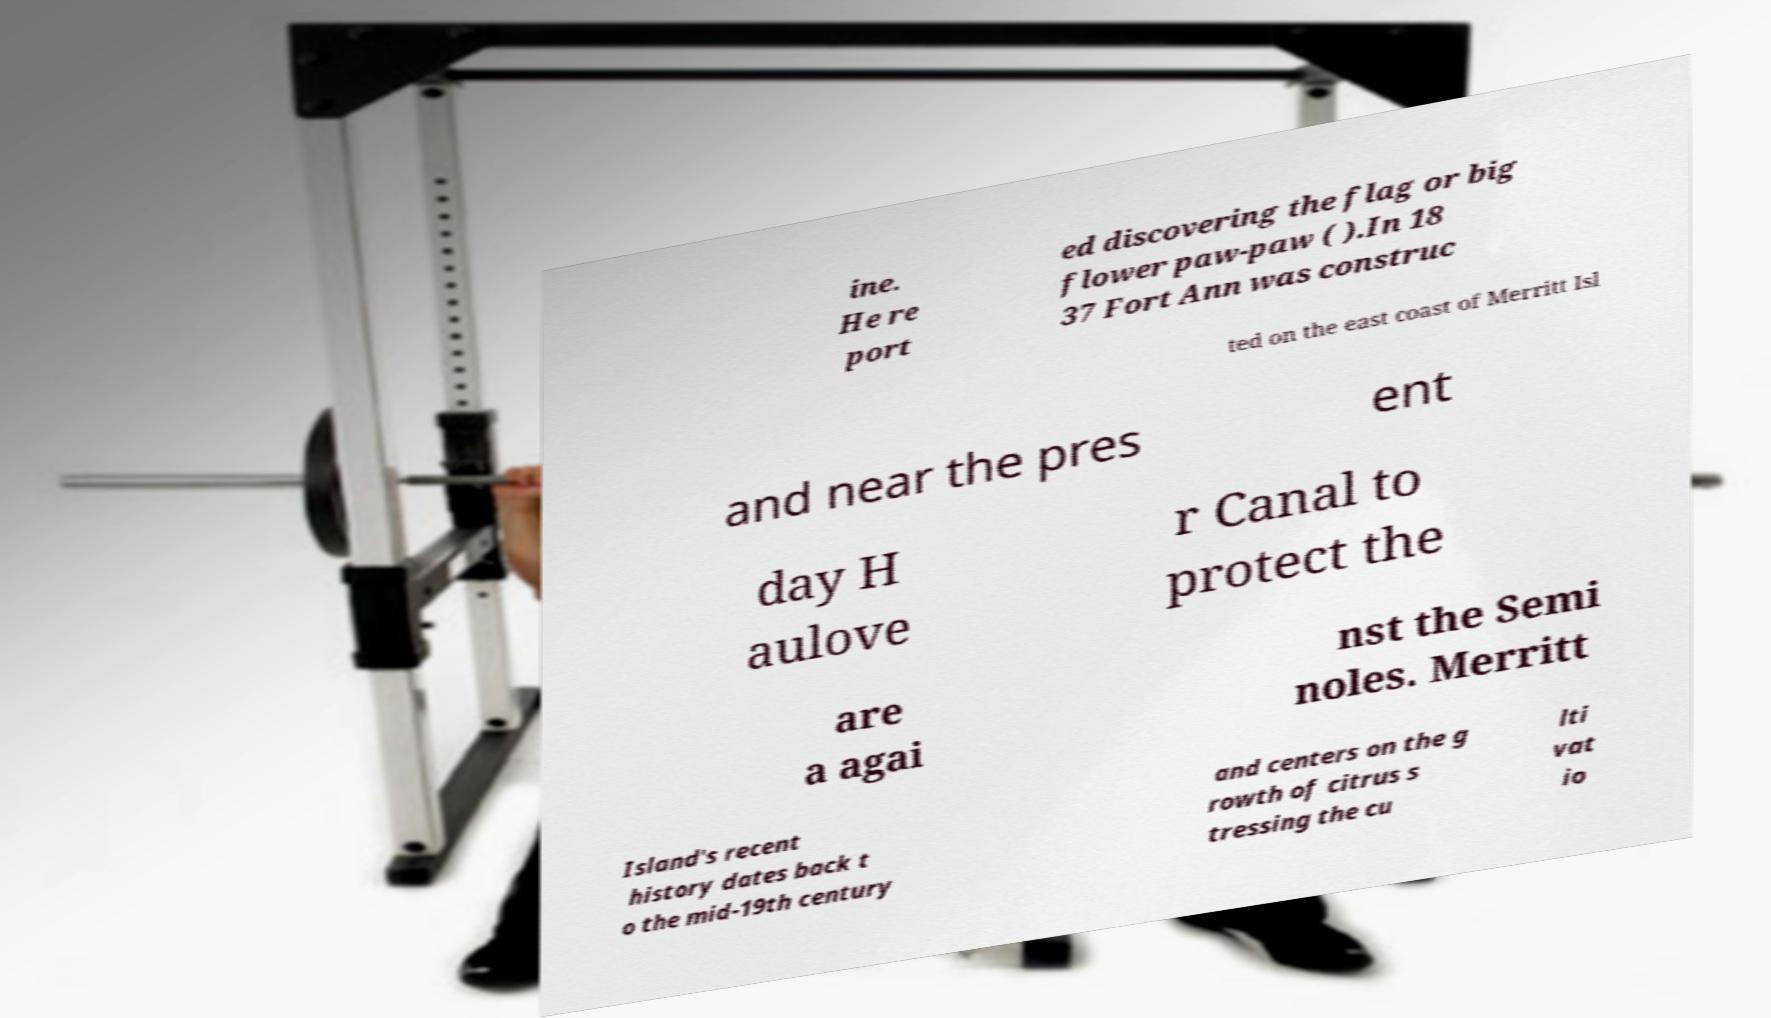Can you read and provide the text displayed in the image?This photo seems to have some interesting text. Can you extract and type it out for me? ine. He re port ed discovering the flag or big flower paw-paw ( ).In 18 37 Fort Ann was construc ted on the east coast of Merritt Isl and near the pres ent day H aulove r Canal to protect the are a agai nst the Semi noles. Merritt Island's recent history dates back t o the mid-19th century and centers on the g rowth of citrus s tressing the cu lti vat io 